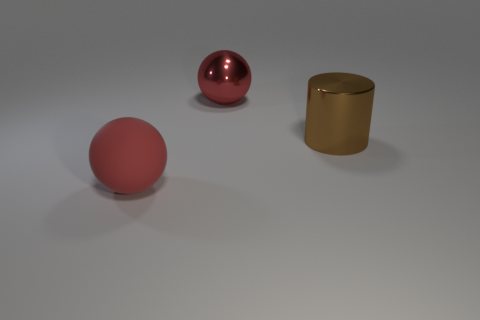There is a object that is to the left of the big brown object and to the right of the large red rubber object; what color is it?
Offer a terse response. Red. Is the large red thing to the right of the large rubber thing made of the same material as the big brown cylinder?
Offer a very short reply. Yes. There is a big metallic sphere; does it have the same color as the big thing that is in front of the big brown object?
Keep it short and to the point. Yes. There is a large rubber ball; are there any large metal cylinders in front of it?
Offer a terse response. No. There is a object behind the metallic cylinder; is its size the same as the object that is in front of the large brown object?
Keep it short and to the point. Yes. Are there any green matte objects that have the same size as the red matte ball?
Provide a succinct answer. No. There is a red thing that is on the right side of the big red matte object; is it the same shape as the red rubber object?
Offer a terse response. Yes. There is a big ball behind the cylinder; what is it made of?
Provide a short and direct response. Metal. There is a thing on the right side of the big red object behind the rubber thing; what is its shape?
Ensure brevity in your answer.  Cylinder. There is a red metallic thing; is it the same shape as the red object that is in front of the big red metal thing?
Provide a short and direct response. Yes. 